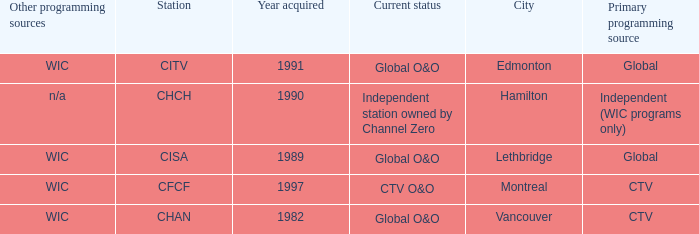How any were gained as the chan 1.0. 